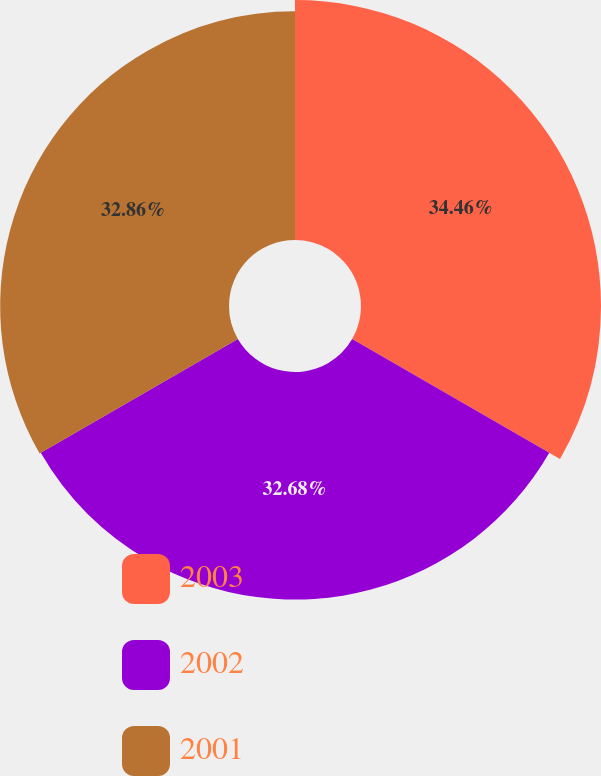<chart> <loc_0><loc_0><loc_500><loc_500><pie_chart><fcel>2003<fcel>2002<fcel>2001<nl><fcel>34.46%<fcel>32.68%<fcel>32.86%<nl></chart> 